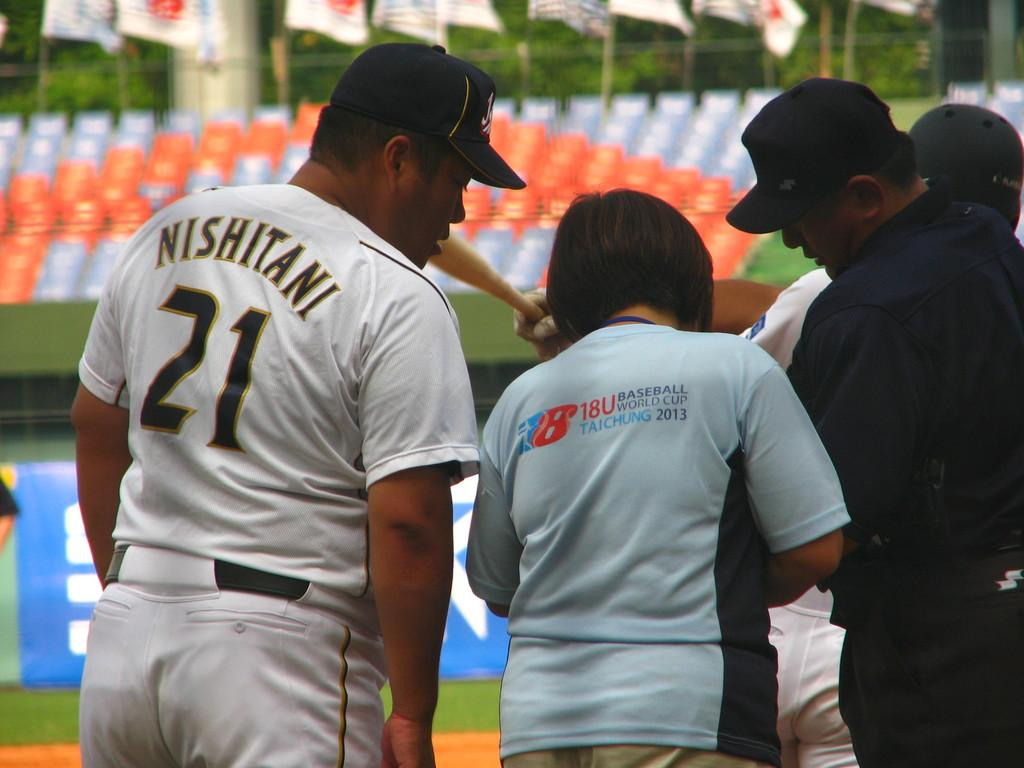<image>
Offer a succinct explanation of the picture presented. A baseball player named Nishitani wears number 21. on his jersey. 